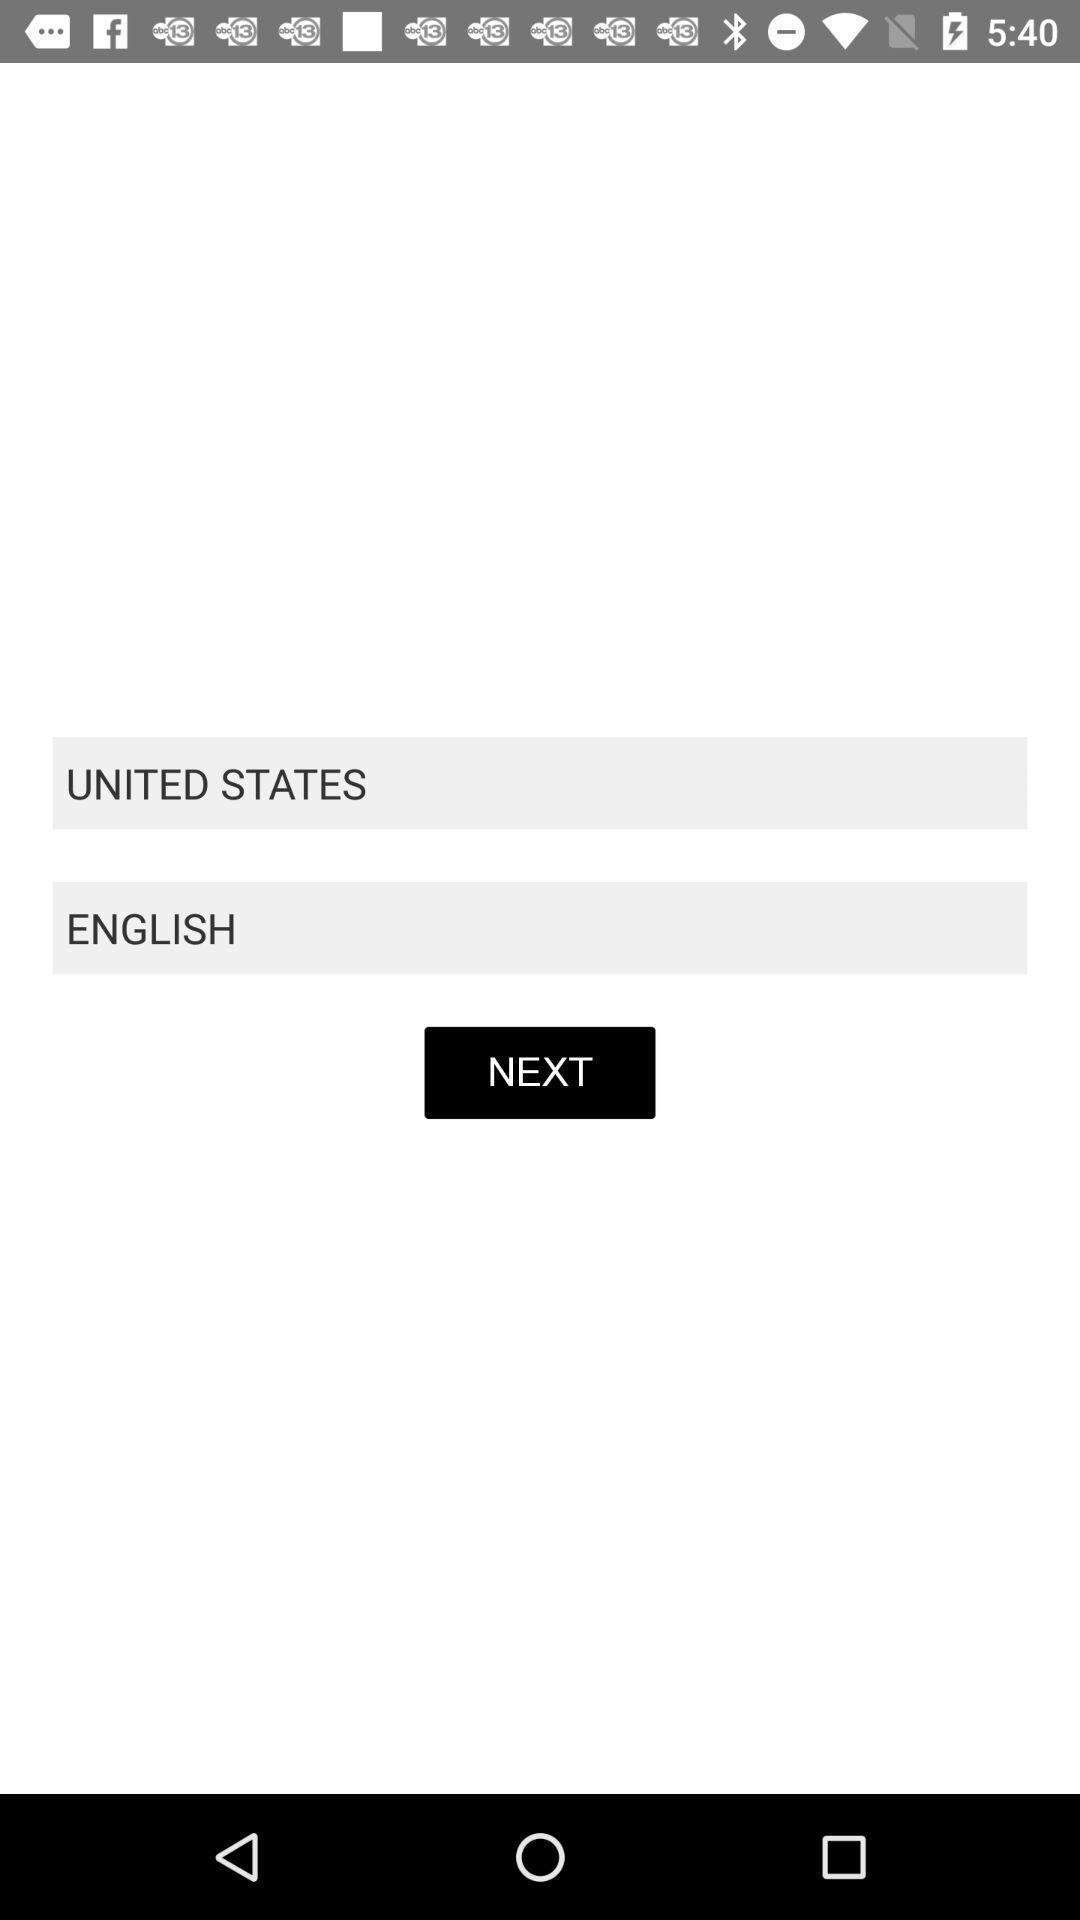What is the overall content of this screenshot? Screen showing country and language options. 